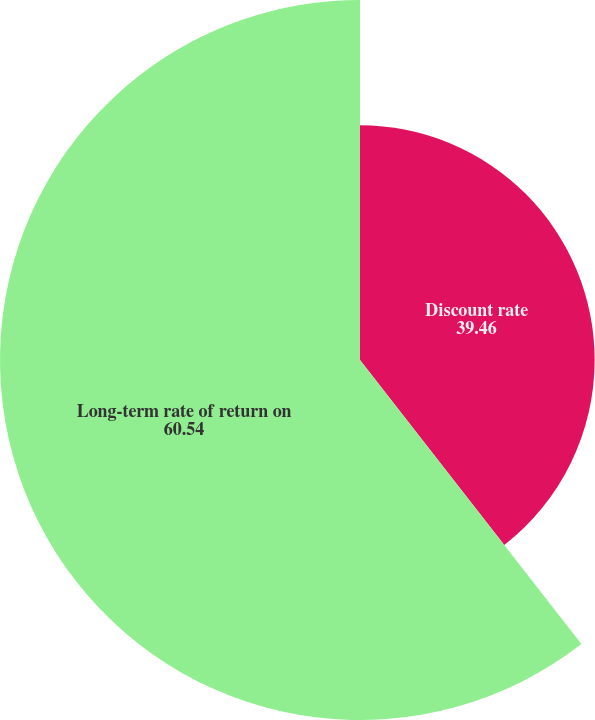Convert chart to OTSL. <chart><loc_0><loc_0><loc_500><loc_500><pie_chart><fcel>Discount rate<fcel>Long-term rate of return on<nl><fcel>39.46%<fcel>60.54%<nl></chart> 